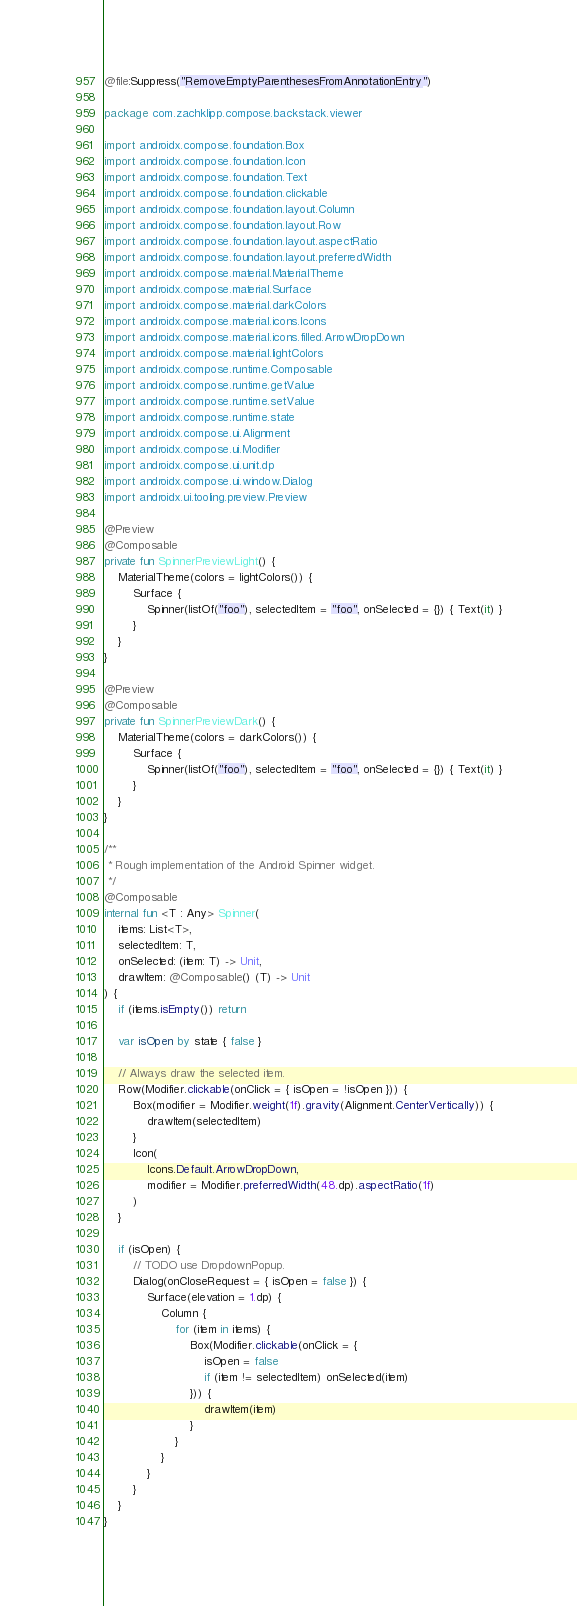<code> <loc_0><loc_0><loc_500><loc_500><_Kotlin_>@file:Suppress("RemoveEmptyParenthesesFromAnnotationEntry")

package com.zachklipp.compose.backstack.viewer

import androidx.compose.foundation.Box
import androidx.compose.foundation.Icon
import androidx.compose.foundation.Text
import androidx.compose.foundation.clickable
import androidx.compose.foundation.layout.Column
import androidx.compose.foundation.layout.Row
import androidx.compose.foundation.layout.aspectRatio
import androidx.compose.foundation.layout.preferredWidth
import androidx.compose.material.MaterialTheme
import androidx.compose.material.Surface
import androidx.compose.material.darkColors
import androidx.compose.material.icons.Icons
import androidx.compose.material.icons.filled.ArrowDropDown
import androidx.compose.material.lightColors
import androidx.compose.runtime.Composable
import androidx.compose.runtime.getValue
import androidx.compose.runtime.setValue
import androidx.compose.runtime.state
import androidx.compose.ui.Alignment
import androidx.compose.ui.Modifier
import androidx.compose.ui.unit.dp
import androidx.compose.ui.window.Dialog
import androidx.ui.tooling.preview.Preview

@Preview
@Composable
private fun SpinnerPreviewLight() {
    MaterialTheme(colors = lightColors()) {
        Surface {
            Spinner(listOf("foo"), selectedItem = "foo", onSelected = {}) { Text(it) }
        }
    }
}

@Preview
@Composable
private fun SpinnerPreviewDark() {
    MaterialTheme(colors = darkColors()) {
        Surface {
            Spinner(listOf("foo"), selectedItem = "foo", onSelected = {}) { Text(it) }
        }
    }
}

/**
 * Rough implementation of the Android Spinner widget.
 */
@Composable
internal fun <T : Any> Spinner(
    items: List<T>,
    selectedItem: T,
    onSelected: (item: T) -> Unit,
    drawItem: @Composable() (T) -> Unit
) {
    if (items.isEmpty()) return

    var isOpen by state { false }

    // Always draw the selected item.
    Row(Modifier.clickable(onClick = { isOpen = !isOpen })) {
        Box(modifier = Modifier.weight(1f).gravity(Alignment.CenterVertically)) {
            drawItem(selectedItem)
        }
        Icon(
            Icons.Default.ArrowDropDown,
            modifier = Modifier.preferredWidth(48.dp).aspectRatio(1f)
        )
    }

    if (isOpen) {
        // TODO use DropdownPopup.
        Dialog(onCloseRequest = { isOpen = false }) {
            Surface(elevation = 1.dp) {
                Column {
                    for (item in items) {
                        Box(Modifier.clickable(onClick = {
                            isOpen = false
                            if (item != selectedItem) onSelected(item)
                        })) {
                            drawItem(item)
                        }
                    }
                }
            }
        }
    }
}
</code> 